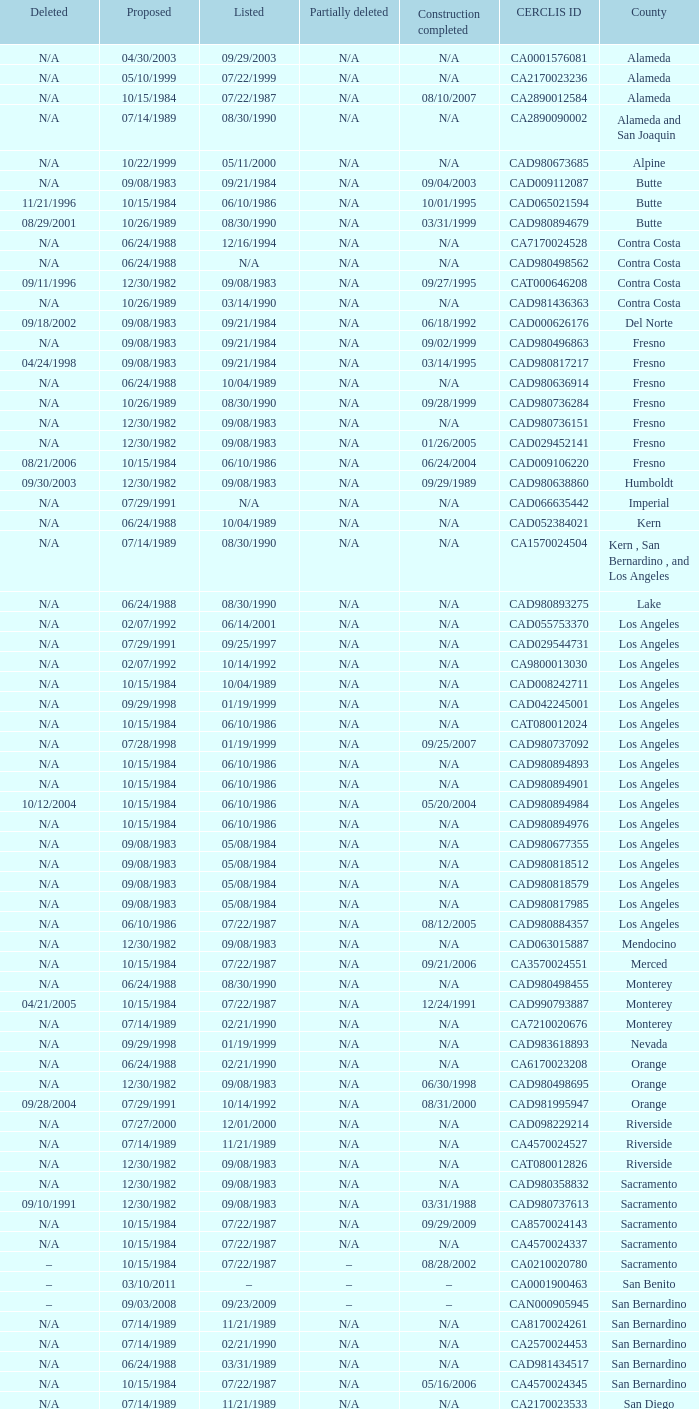What construction completed on 08/10/2007? 07/22/1987. 